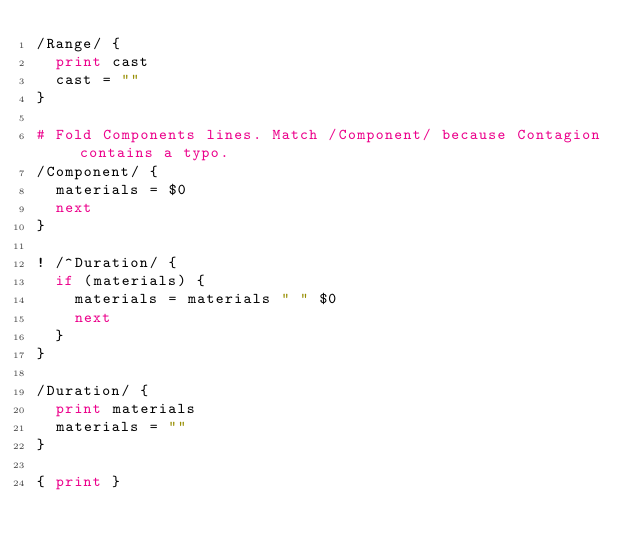<code> <loc_0><loc_0><loc_500><loc_500><_Awk_>/Range/ {
  print cast
  cast = ""
}

# Fold Components lines. Match /Component/ because Contagion contains a typo.
/Component/ {
  materials = $0
  next
}

! /^Duration/ {
  if (materials) {
    materials = materials " " $0
    next
  }
}

/Duration/ {
  print materials
  materials = ""
}

{ print }
</code> 